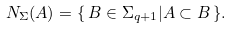Convert formula to latex. <formula><loc_0><loc_0><loc_500><loc_500>N _ { \Sigma } ( A ) = \{ \, B \in \Sigma _ { q + 1 } | A \subset B \, \} .</formula> 